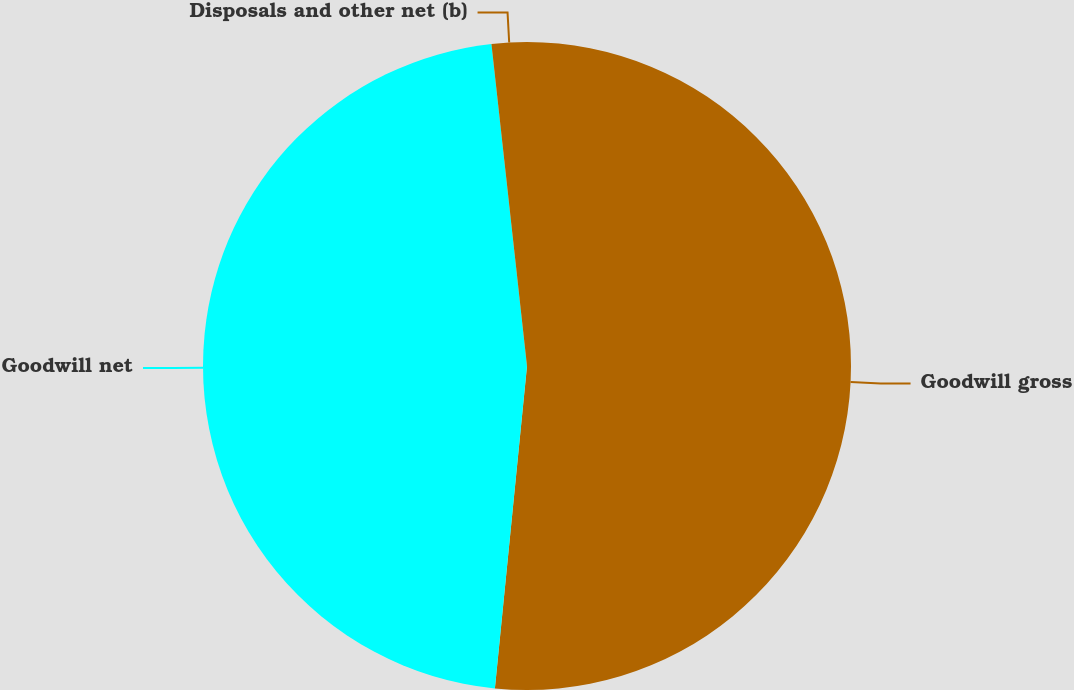<chart> <loc_0><loc_0><loc_500><loc_500><pie_chart><fcel>Goodwill gross<fcel>Goodwill net<fcel>Disposals and other net (b)<nl><fcel>51.58%<fcel>46.67%<fcel>1.75%<nl></chart> 